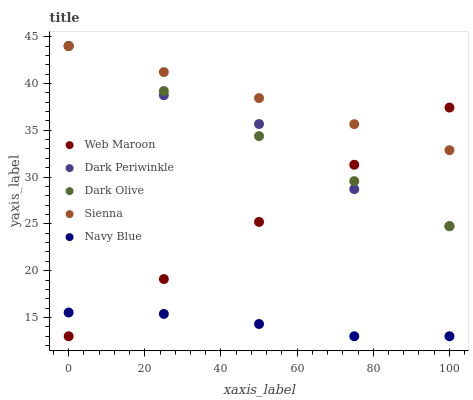Does Navy Blue have the minimum area under the curve?
Answer yes or no. Yes. Does Sienna have the maximum area under the curve?
Answer yes or no. Yes. Does Dark Olive have the minimum area under the curve?
Answer yes or no. No. Does Dark Olive have the maximum area under the curve?
Answer yes or no. No. Is Web Maroon the smoothest?
Answer yes or no. Yes. Is Dark Periwinkle the roughest?
Answer yes or no. Yes. Is Navy Blue the smoothest?
Answer yes or no. No. Is Navy Blue the roughest?
Answer yes or no. No. Does Navy Blue have the lowest value?
Answer yes or no. Yes. Does Dark Olive have the lowest value?
Answer yes or no. No. Does Dark Periwinkle have the highest value?
Answer yes or no. Yes. Does Navy Blue have the highest value?
Answer yes or no. No. Is Navy Blue less than Dark Periwinkle?
Answer yes or no. Yes. Is Dark Olive greater than Navy Blue?
Answer yes or no. Yes. Does Web Maroon intersect Navy Blue?
Answer yes or no. Yes. Is Web Maroon less than Navy Blue?
Answer yes or no. No. Is Web Maroon greater than Navy Blue?
Answer yes or no. No. Does Navy Blue intersect Dark Periwinkle?
Answer yes or no. No. 